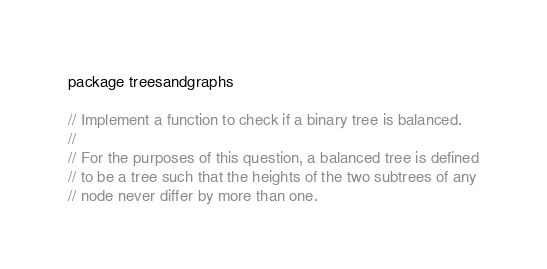Convert code to text. <code><loc_0><loc_0><loc_500><loc_500><_Go_>package treesandgraphs

// Implement a function to check if a binary tree is balanced.
//
// For the purposes of this question, a balanced tree is defined
// to be a tree such that the heights of the two subtrees of any
// node never differ by more than one.
</code> 